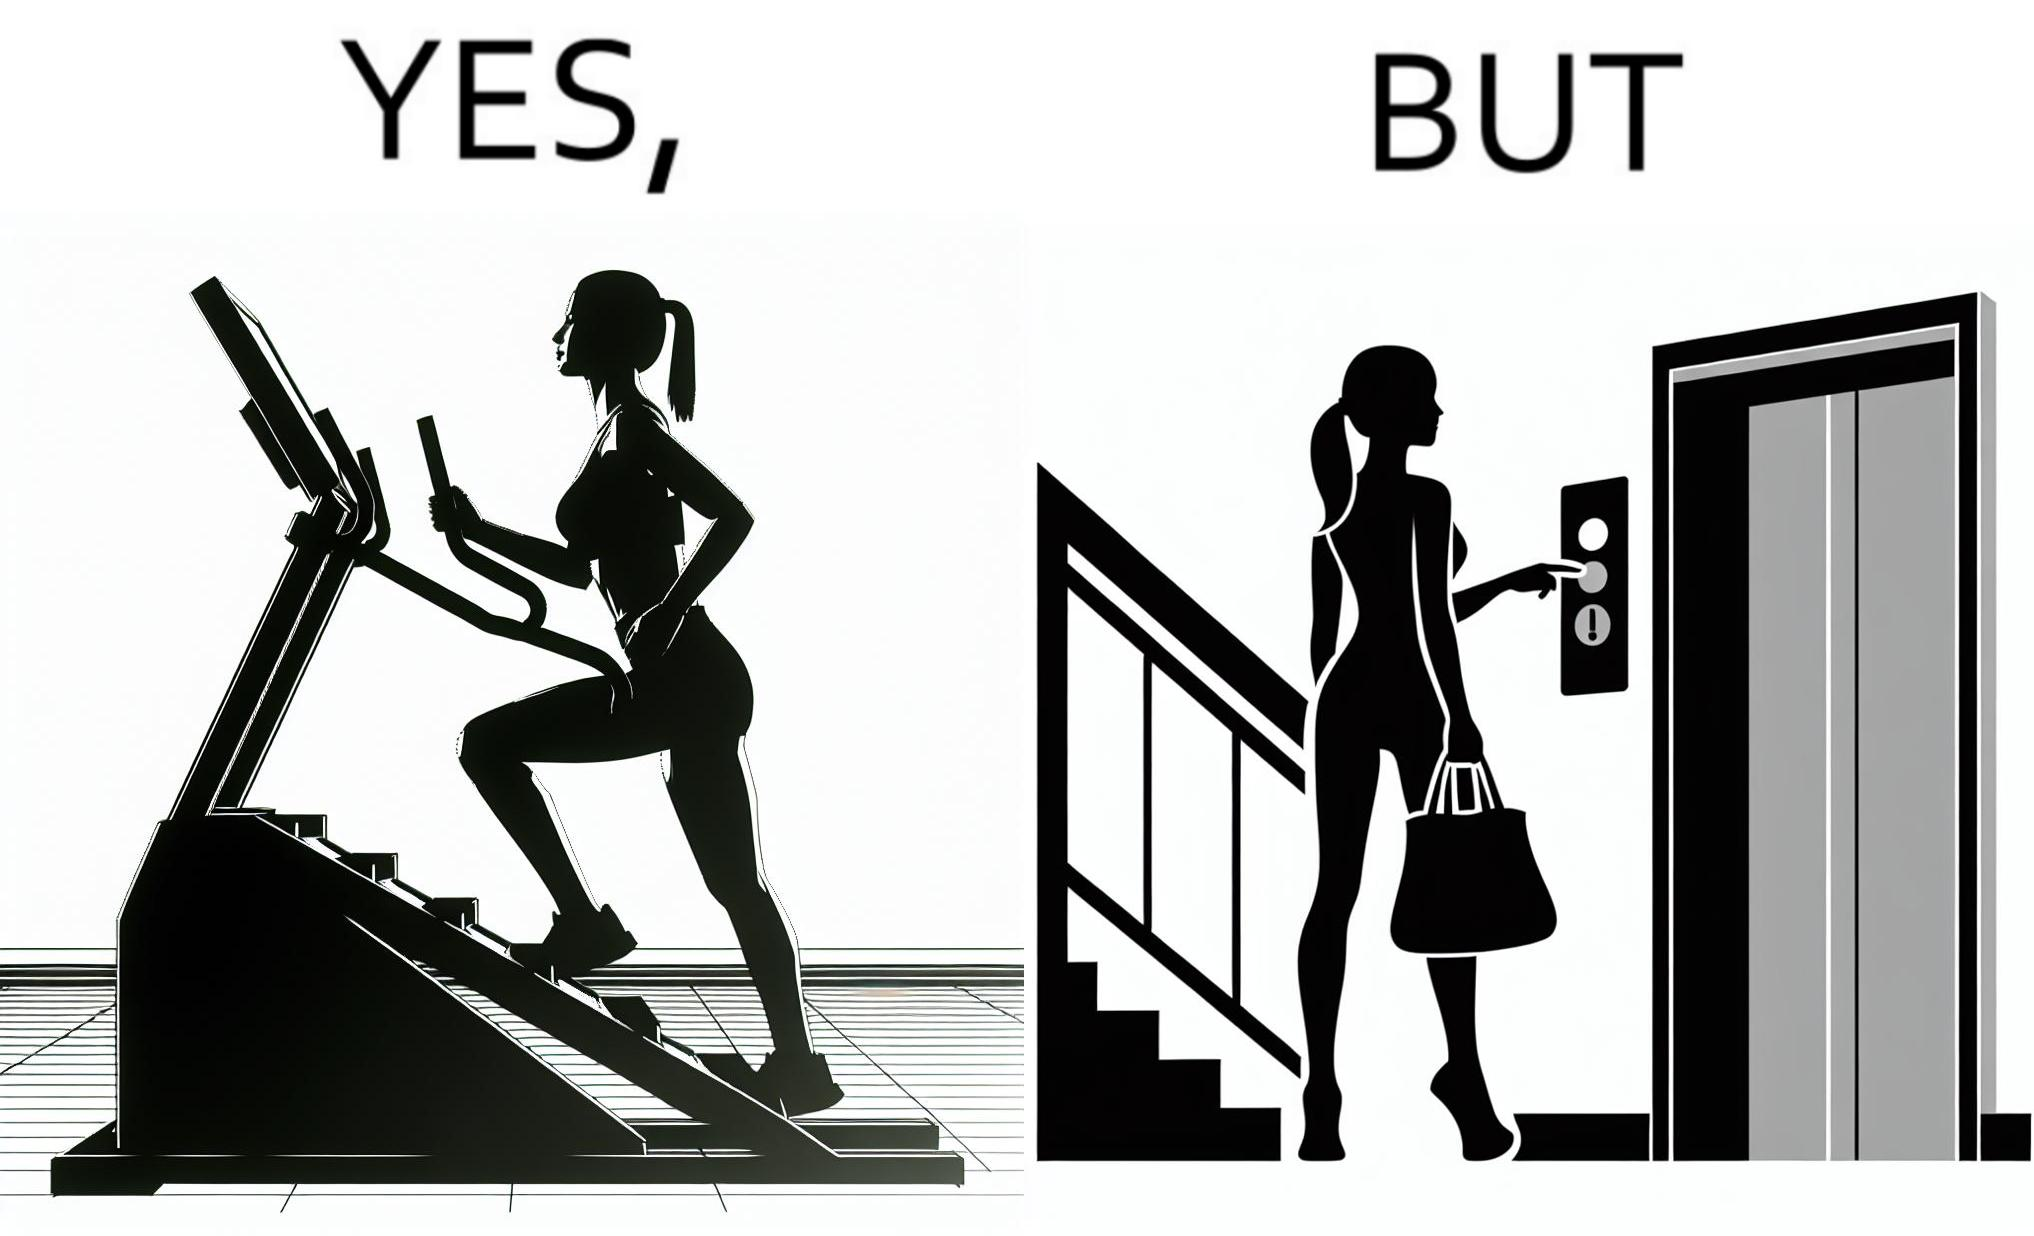Is this a satirical image? Yes, this image is satirical. 